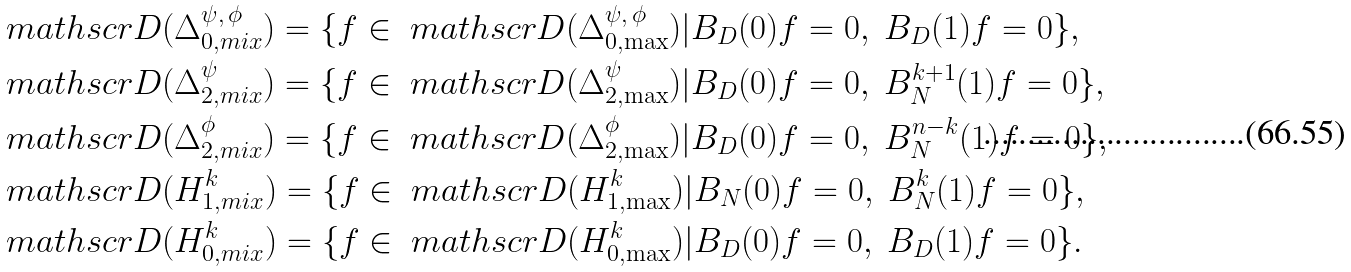Convert formula to latex. <formula><loc_0><loc_0><loc_500><loc_500>& \ m a t h s c r { D } ( \Delta _ { 0 , m i x } ^ { \psi , \, \phi } ) = \{ f \in \ m a t h s c r { D } ( \Delta _ { 0 , \max } ^ { \psi , \, \phi } ) | B _ { D } ( 0 ) f = 0 , \ B _ { D } ( 1 ) f = 0 \} , \\ & \ m a t h s c r { D } ( \Delta _ { 2 , m i x } ^ { \psi } ) = \{ f \in \ m a t h s c r { D } ( \Delta _ { 2 , \max } ^ { \psi } ) | B _ { D } ( 0 ) f = 0 , \ B _ { N } ^ { k + 1 } ( 1 ) f = 0 \} , \\ & \ m a t h s c r { D } ( \Delta _ { 2 , m i x } ^ { \phi } ) = \{ f \in \ m a t h s c r { D } ( \Delta _ { 2 , \max } ^ { \phi } ) | B _ { D } ( 0 ) f = 0 , \ B _ { N } ^ { n - k } ( 1 ) f = 0 \} , \\ & \ m a t h s c r { D } ( H ^ { k } _ { 1 , m i x } ) = \{ f \in \ m a t h s c r { D } ( H ^ { k } _ { 1 , \max } ) | B _ { N } ( 0 ) f = 0 , \ B _ { N } ^ { k } ( 1 ) f = 0 \} , \\ & \ m a t h s c r { D } ( H ^ { k } _ { 0 , m i x } ) = \{ f \in \ m a t h s c r { D } ( H ^ { k } _ { 0 , \max } ) | B _ { D } ( 0 ) f = 0 , \ B _ { D } ( 1 ) f = 0 \} .</formula> 